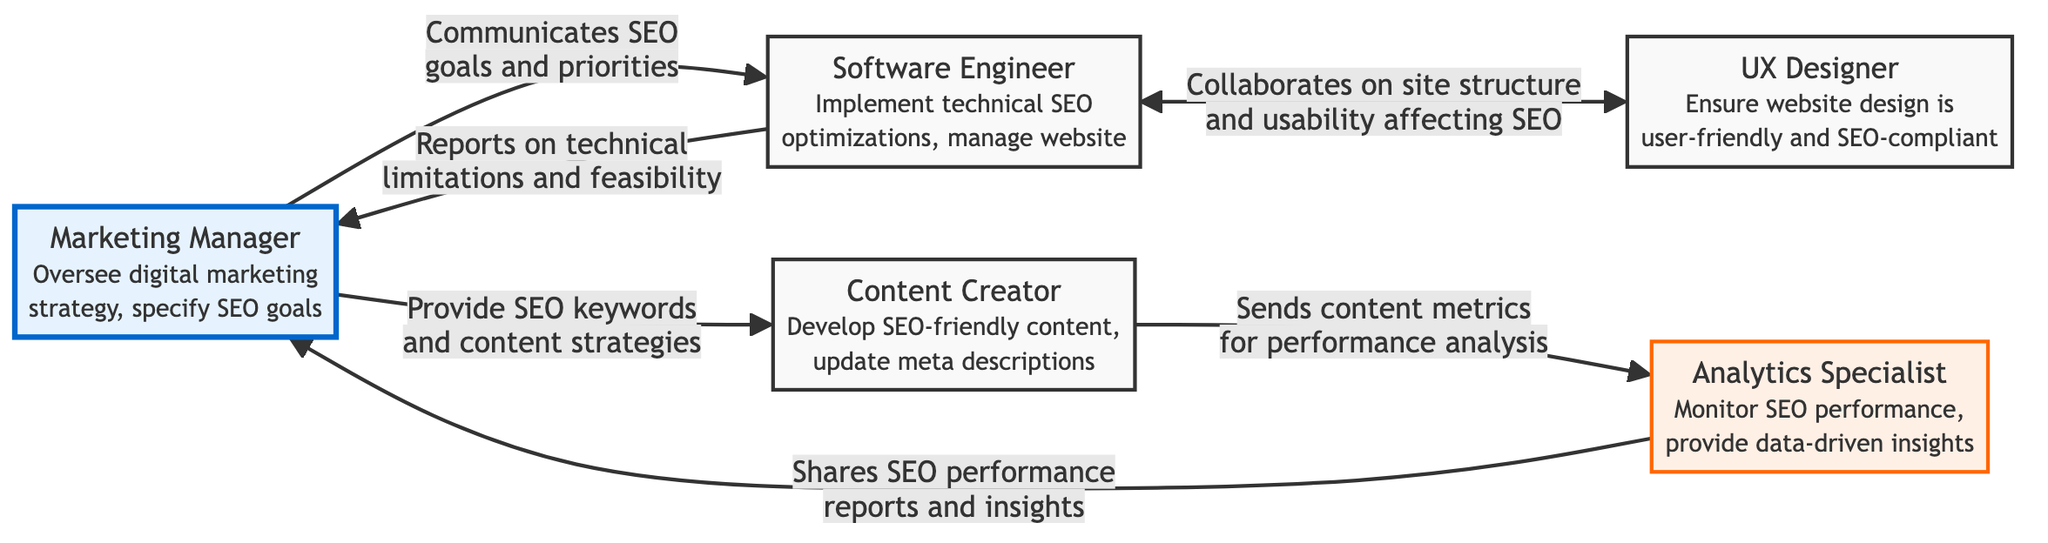What is the total number of nodes in the diagram? The diagram lists five distinct roles: Marketing Manager, Software Engineer, Content Creator, Analytics Specialist, and UX Designer. Counting each of these roles gives a total of five nodes.
Answer: 5 Who communicates SEO goals and priorities to the Software Engineer? The arrow in the diagram from the Marketing Manager to the Software Engineer indicates that the Marketing Manager is responsible for communicating SEO goals and priorities.
Answer: Marketing Manager What type of insights does the Analytics Specialist provide? The relationship from the Analytics Specialist to the Marketing Manager is labeled "Shares SEO performance reports and insights," indicating that the insights are specifically related to SEO performance.
Answer: SEO performance reports and insights Which role sends content metrics for performance analysis? The diagram shows an arrow from the Content Creator to the Analytics Specialist, indicating that the Content Creator is responsible for sending content metrics for performance analysis.
Answer: Content Creator How many direct communications are there between the Marketing Manager and the Software Engineer? There are two directed edges present: one from the Marketing Manager to the Software Engineer (communicating goals) and one from the Software Engineer back to the Marketing Manager (reporting limitations). Therefore, there are two direct communications.
Answer: 2 Which two roles collaborate on site structure and usability affecting SEO? The directed link from the Software Engineer to the UX Designer and the reverse link indicates that both roles are involved in collaborating on site structure and usability affecting SEO.
Answer: Software Engineer and UX Designer What role is responsible for developing SEO-friendly content? The diagram shows that the Content Creator is specifically tasked with developing SEO-friendly content, as stated in the role description associated with the node.
Answer: Content Creator How many different responsibilities are outlined for the Software Engineer? The responsibilities of the Software Engineer include implementing technical SEO optimizations and managing website infrastructure. Summing these confirms that there are two distinct responsibilities noted for the Software Engineer.
Answer: 2 What does the UX Designer ensure is user-friendly? The diagram indicates that the UX Designer ensures that the website design is user-friendly and SEO-compliant, as per the role's description.
Answer: Website design 